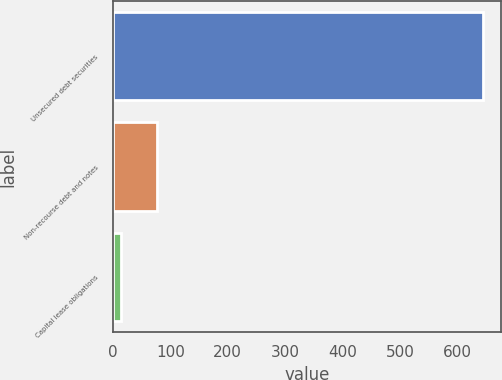Convert chart to OTSL. <chart><loc_0><loc_0><loc_500><loc_500><bar_chart><fcel>Unsecured debt securities<fcel>Non-recourse debt and notes<fcel>Capital lease obligations<nl><fcel>644<fcel>77<fcel>14<nl></chart> 